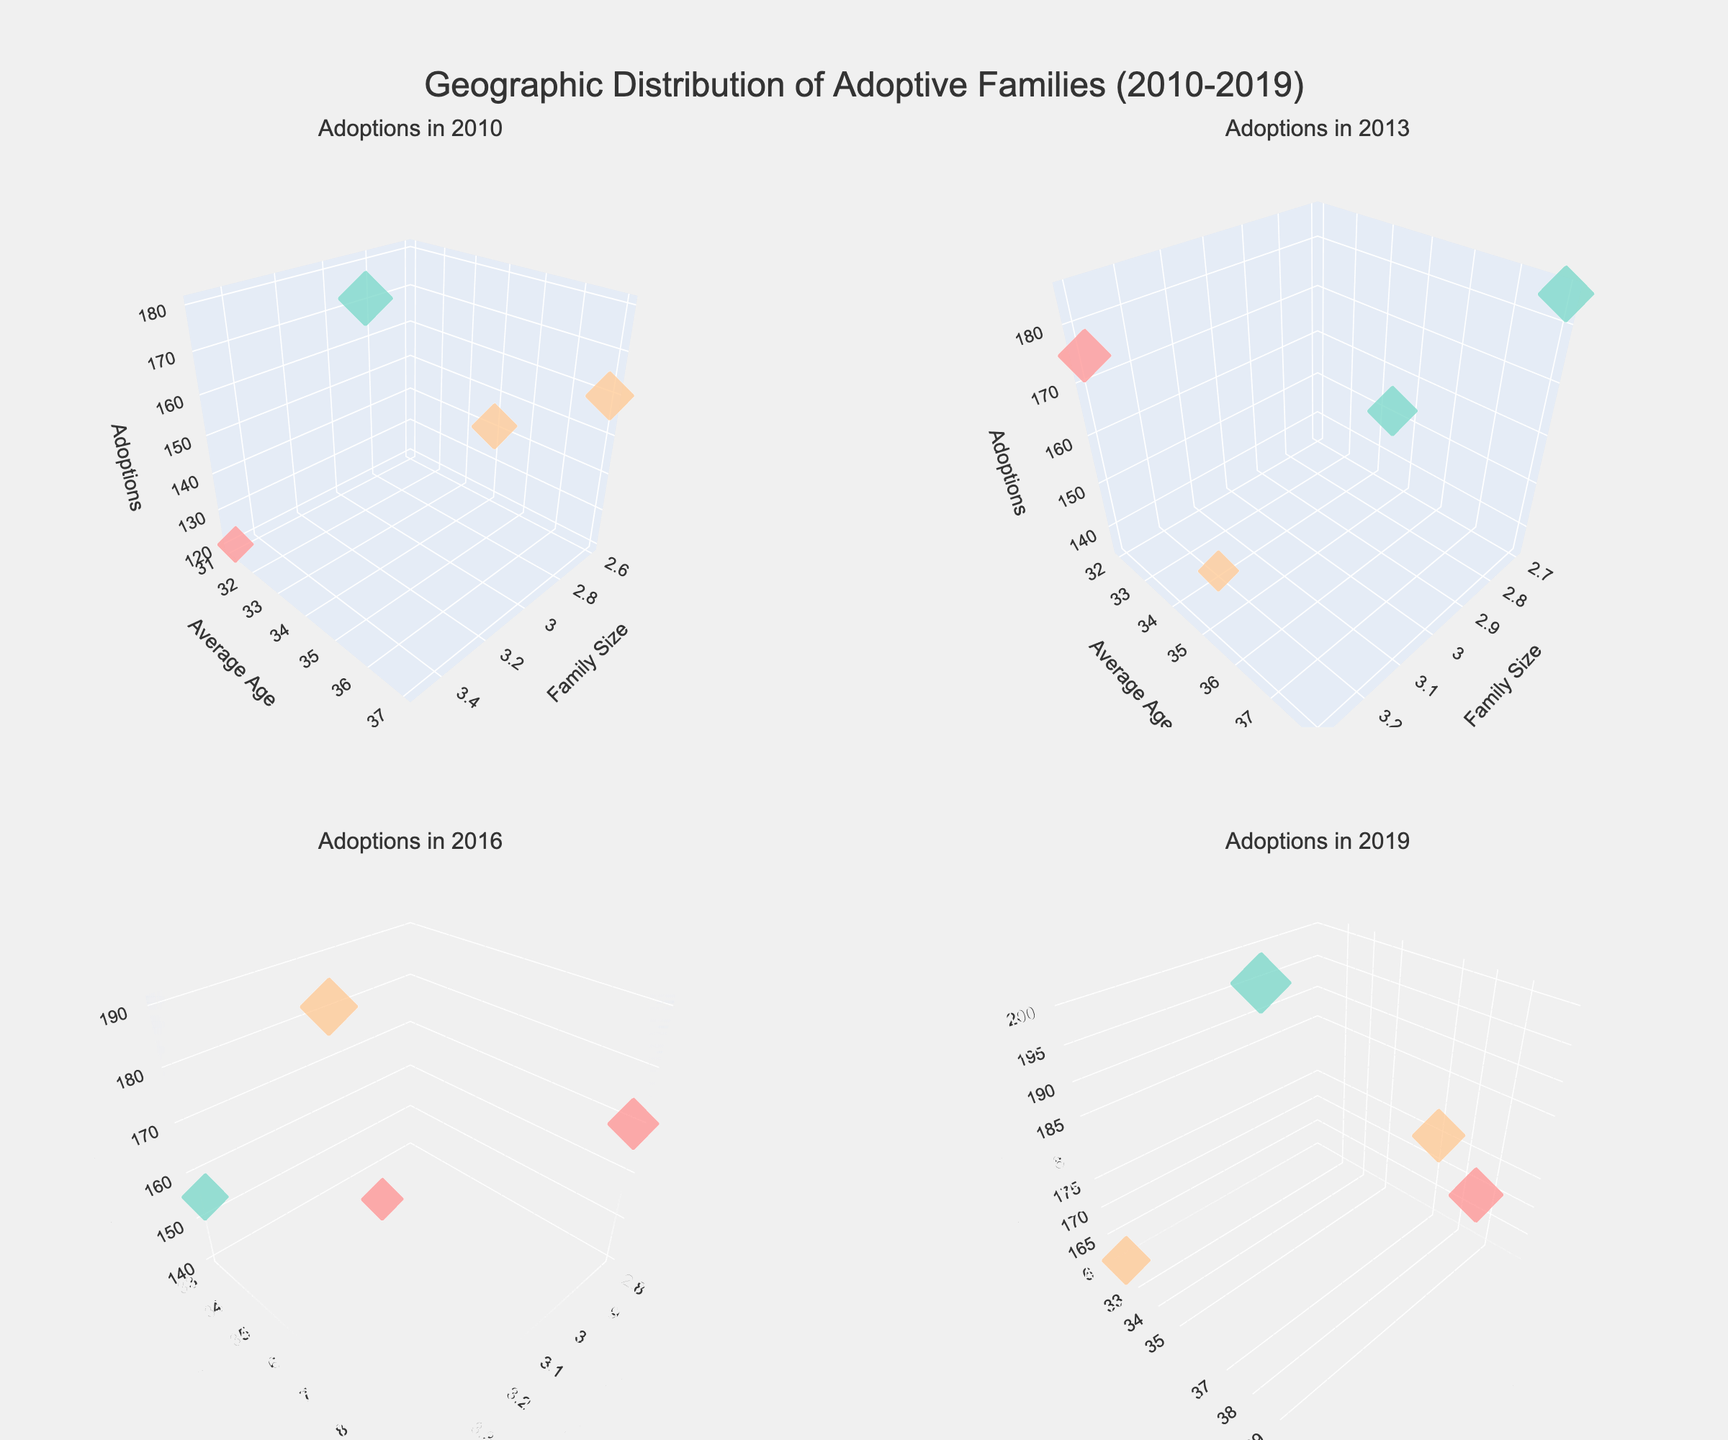What's the title of the figure? The title of the figure is prominently displayed at the top of the image.
Answer: Geographic Distribution of Adoptive Families (2010-2019) What does the color of the markers represent? By looking at the color legend or different marker colors across different income levels, we can infer that the color of the markers represents the income level of the adoptive families (High, Middle, Low).
Answer: Income level Which region had the highest number of adoptions in 2019? In the subplot titled 'Adoptions in 2019', we look for the marker with the highest z-value (Adoptions) and check its hover text or color. The largest marker is in the Midwest region.
Answer: Midwest How does the family size impact the number of adoptions across regions in 2010? In the 'Adoptions in 2010' subplot, observe the x-axis (Family Size) and corresponding z-values (Adoptions) for different regions. Larger family sizes generally correlate with more adoptions in the Midwest and South.
Answer: Larger family sizes tend to correlate with more adoptions in the Midwest and South Compare the average age of adoptive parents in the Northeast region between 2010 and 2019. Look at the 'Average Age' on the y-axis for the Northeast region markers in the subplots for 2010 and 2019. In 2010, the average age was 35, and in 2019 it was 37.
Answer: The average age increased from 35 to 37 Which year saw the highest socioeconomic diversity among adoptive families? By comparing the range of marker colors in each subplot (representing different income levels), we see that 2013 shows a greater mix of all three income levels across regions.
Answer: 2013 How many regions had greater than 150 adoptions in 2016? In the 'Adoptions in 2016' subplot, count the markers with z-values (Adoptions) greater than 150. There are three regions (Midwest, South, West).
Answer: Three regions Which year had the smallest family sizes among adoptive families in the Midwest? In each subplot, find the Midwest markers and observe the values on the x-axis (Family Size). In 2010, the family size was 3.1, which is the smallest compared to other years.
Answer: 2010 In which region were the adoptive parents the youngest in 2013? By looking at the 'Average Age' (y-axis) in the 'Adoptions in 2013' subplot, find the region marker with the lowest y-value. This is the South region with an average age of 32.
Answer: South 